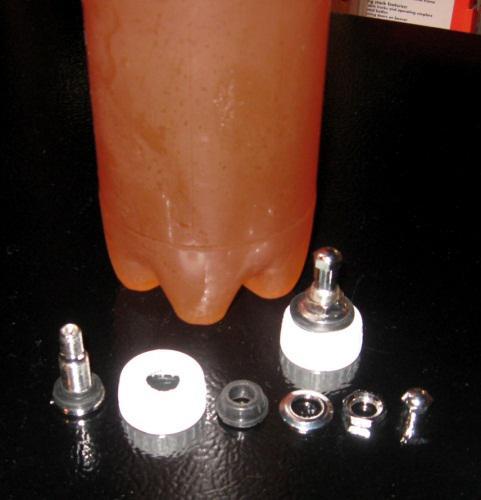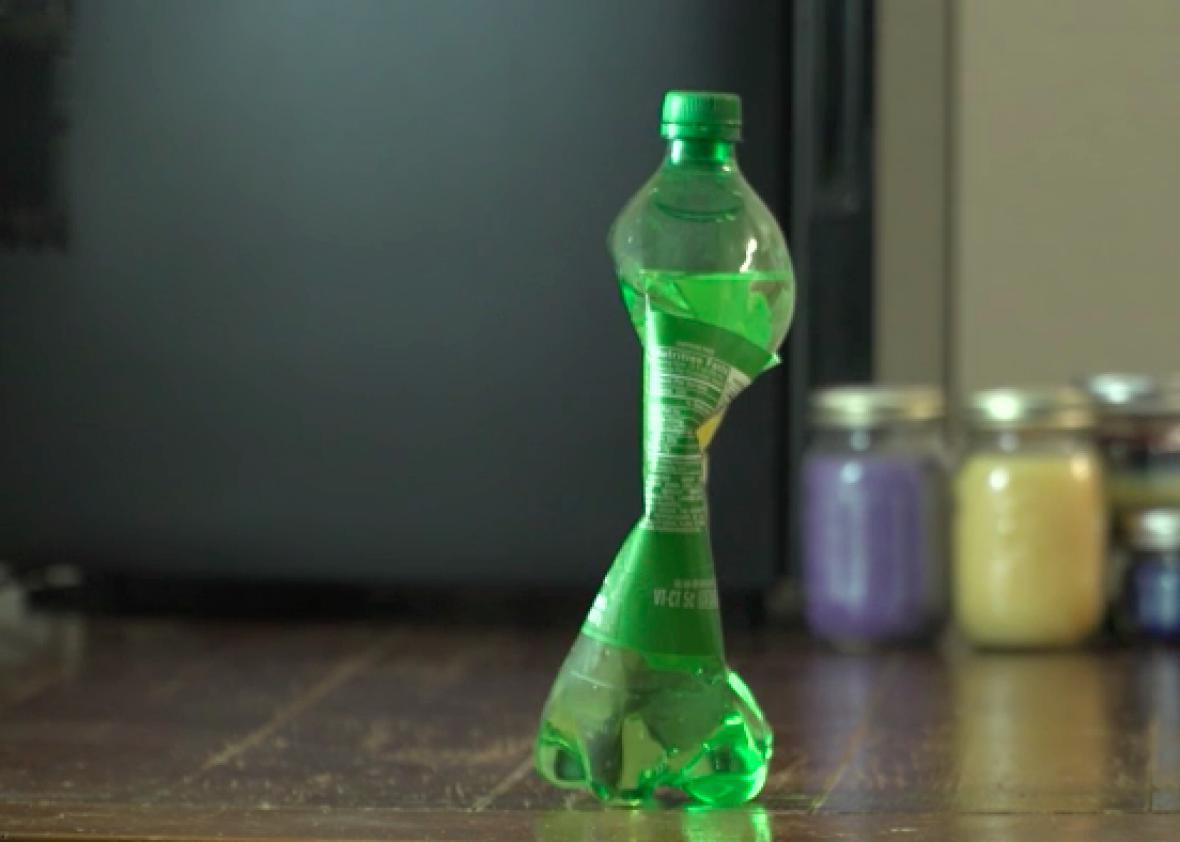The first image is the image on the left, the second image is the image on the right. Analyze the images presented: Is the assertion "There are at least two hands." valid? Answer yes or no. No. The first image is the image on the left, the second image is the image on the right. Assess this claim about the two images: "There is at least one  twisted  or crushed soda bottle". Correct or not? Answer yes or no. Yes. 